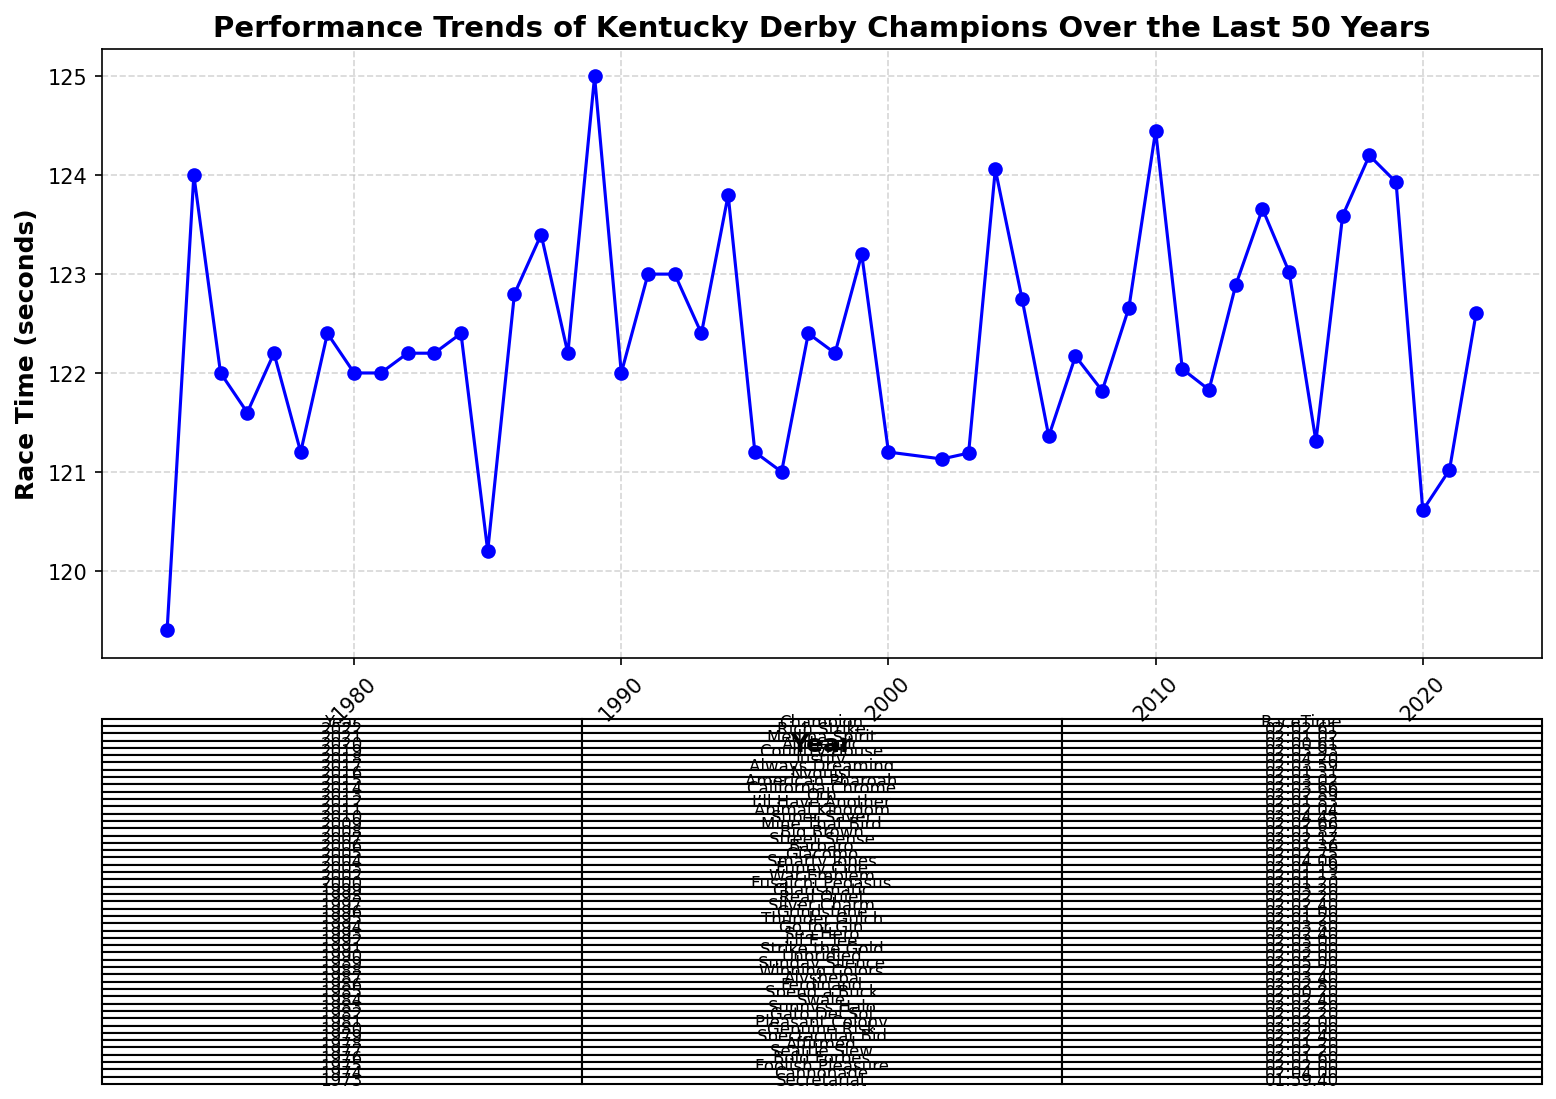What was the race time for the Kentucky Derby champion in 1980? Look at the table provided below the plot and locate the "1980" entry, then check the corresponding race time.
Answer: 02:02.00 Which champion had the fastest race time? Examine the plot for the lowest point on the curve as well as the table to identify the corresponding champion. The fastest race time is seen as the minimum y-value on the plot.
Answer: Secretariat By how much did the race time improve from 1973 to 2020? Refer to the table for Secretariat's (1973) time and Authentic's (2020) time. Secretariat had a race time of 01:59.40 and Authentic had a time of 02:00.61. Time difference calculation: 02:00.61 - 01:59.40 = 1.21 seconds.
Answer: 1.21 seconds Which year had the race time closest to 02:03.00? Locate entries in the table near the 02:03.00 mark and find the one closest in value.
Answer: 1991 How many champions had race times under 02:02.00? Check each race time in the table to find the number of instances where the race time is less than 02:02.00. Count these entries.
Answer: 10 Who were the champions with race times over 02:04.00? Check the table for entries with race times exceeding 02:04.00 and list their names.
Answer: Cannonade, Sunday Silence, Smarty Jones, Super Saver, California Chrome, Justify What’s the average race time over the last 10 years (2013-2022)? From the table, identify race times for champions from 2013 to 2022. Convert these times to seconds for calculation. Average is the sum of these race times divided by 10. Steps: (02:02.89+02:03.66+02:03.02+02:01.31+02:03.59+02:04.20+02:03.93+02:00.61+02:01.02+02:02.61) in seconds. Average in seconds and then convert back to minutes:seconds.
Answer: Approx. 02:02.94 Which year had the biggest improvement in race time compared to the previous year? Calculate the year-to-year differences in race times based on the plot/table. Identify the year corresponding to the maximum improvement (biggest negative difference).
Answer: 1976 (Bold Forbes improved significantly over Foolish Pleasure) What trend can be observed in race times from 1973 to 2022? Look at the general trend of the line plot from 1973 to 2022 to identify whether race times are becoming faster, slower, or if there is no clear trend.
Answer: Overall, the race times show a slight decreasing trend, indicating slight improvements in speed over time 